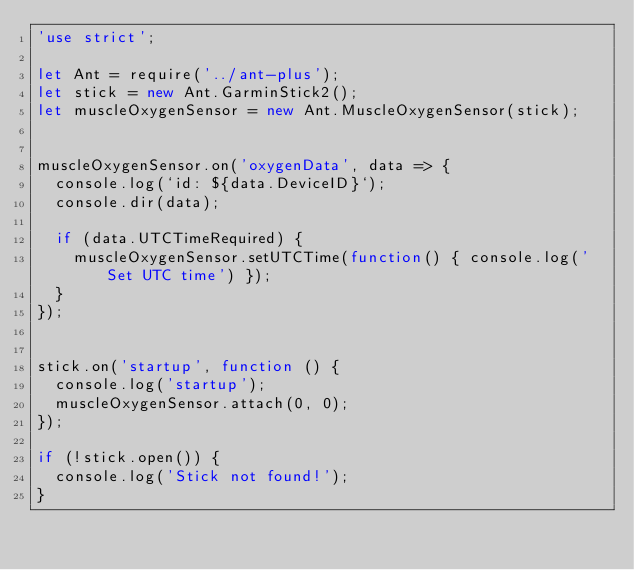Convert code to text. <code><loc_0><loc_0><loc_500><loc_500><_JavaScript_>'use strict';

let Ant = require('../ant-plus');
let stick = new Ant.GarminStick2();
let muscleOxygenSensor = new Ant.MuscleOxygenSensor(stick);


muscleOxygenSensor.on('oxygenData', data => {
	console.log(`id: ${data.DeviceID}`);
	console.dir(data);

	if (data.UTCTimeRequired) {
		muscleOxygenSensor.setUTCTime(function() { console.log('Set UTC time') });
	}
});


stick.on('startup', function () {
	console.log('startup');
	muscleOxygenSensor.attach(0, 0);
});

if (!stick.open()) {
	console.log('Stick not found!');
}
</code> 